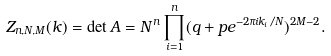<formula> <loc_0><loc_0><loc_500><loc_500>Z _ { n , N , M } ( k ) = \det A = N ^ { n } \prod _ { i = 1 } ^ { n } ( q + p e ^ { - 2 \pi i k _ { i } / N } ) ^ { 2 M - 2 } .</formula> 